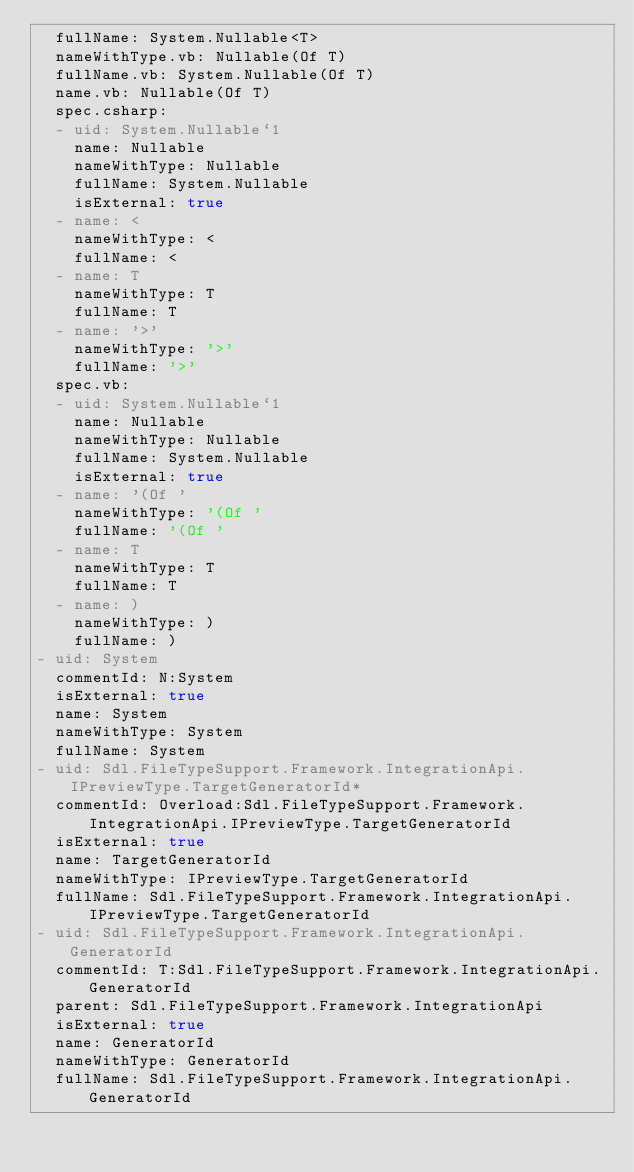<code> <loc_0><loc_0><loc_500><loc_500><_YAML_>  fullName: System.Nullable<T>
  nameWithType.vb: Nullable(Of T)
  fullName.vb: System.Nullable(Of T)
  name.vb: Nullable(Of T)
  spec.csharp:
  - uid: System.Nullable`1
    name: Nullable
    nameWithType: Nullable
    fullName: System.Nullable
    isExternal: true
  - name: <
    nameWithType: <
    fullName: <
  - name: T
    nameWithType: T
    fullName: T
  - name: '>'
    nameWithType: '>'
    fullName: '>'
  spec.vb:
  - uid: System.Nullable`1
    name: Nullable
    nameWithType: Nullable
    fullName: System.Nullable
    isExternal: true
  - name: '(Of '
    nameWithType: '(Of '
    fullName: '(Of '
  - name: T
    nameWithType: T
    fullName: T
  - name: )
    nameWithType: )
    fullName: )
- uid: System
  commentId: N:System
  isExternal: true
  name: System
  nameWithType: System
  fullName: System
- uid: Sdl.FileTypeSupport.Framework.IntegrationApi.IPreviewType.TargetGeneratorId*
  commentId: Overload:Sdl.FileTypeSupport.Framework.IntegrationApi.IPreviewType.TargetGeneratorId
  isExternal: true
  name: TargetGeneratorId
  nameWithType: IPreviewType.TargetGeneratorId
  fullName: Sdl.FileTypeSupport.Framework.IntegrationApi.IPreviewType.TargetGeneratorId
- uid: Sdl.FileTypeSupport.Framework.IntegrationApi.GeneratorId
  commentId: T:Sdl.FileTypeSupport.Framework.IntegrationApi.GeneratorId
  parent: Sdl.FileTypeSupport.Framework.IntegrationApi
  isExternal: true
  name: GeneratorId
  nameWithType: GeneratorId
  fullName: Sdl.FileTypeSupport.Framework.IntegrationApi.GeneratorId
</code> 